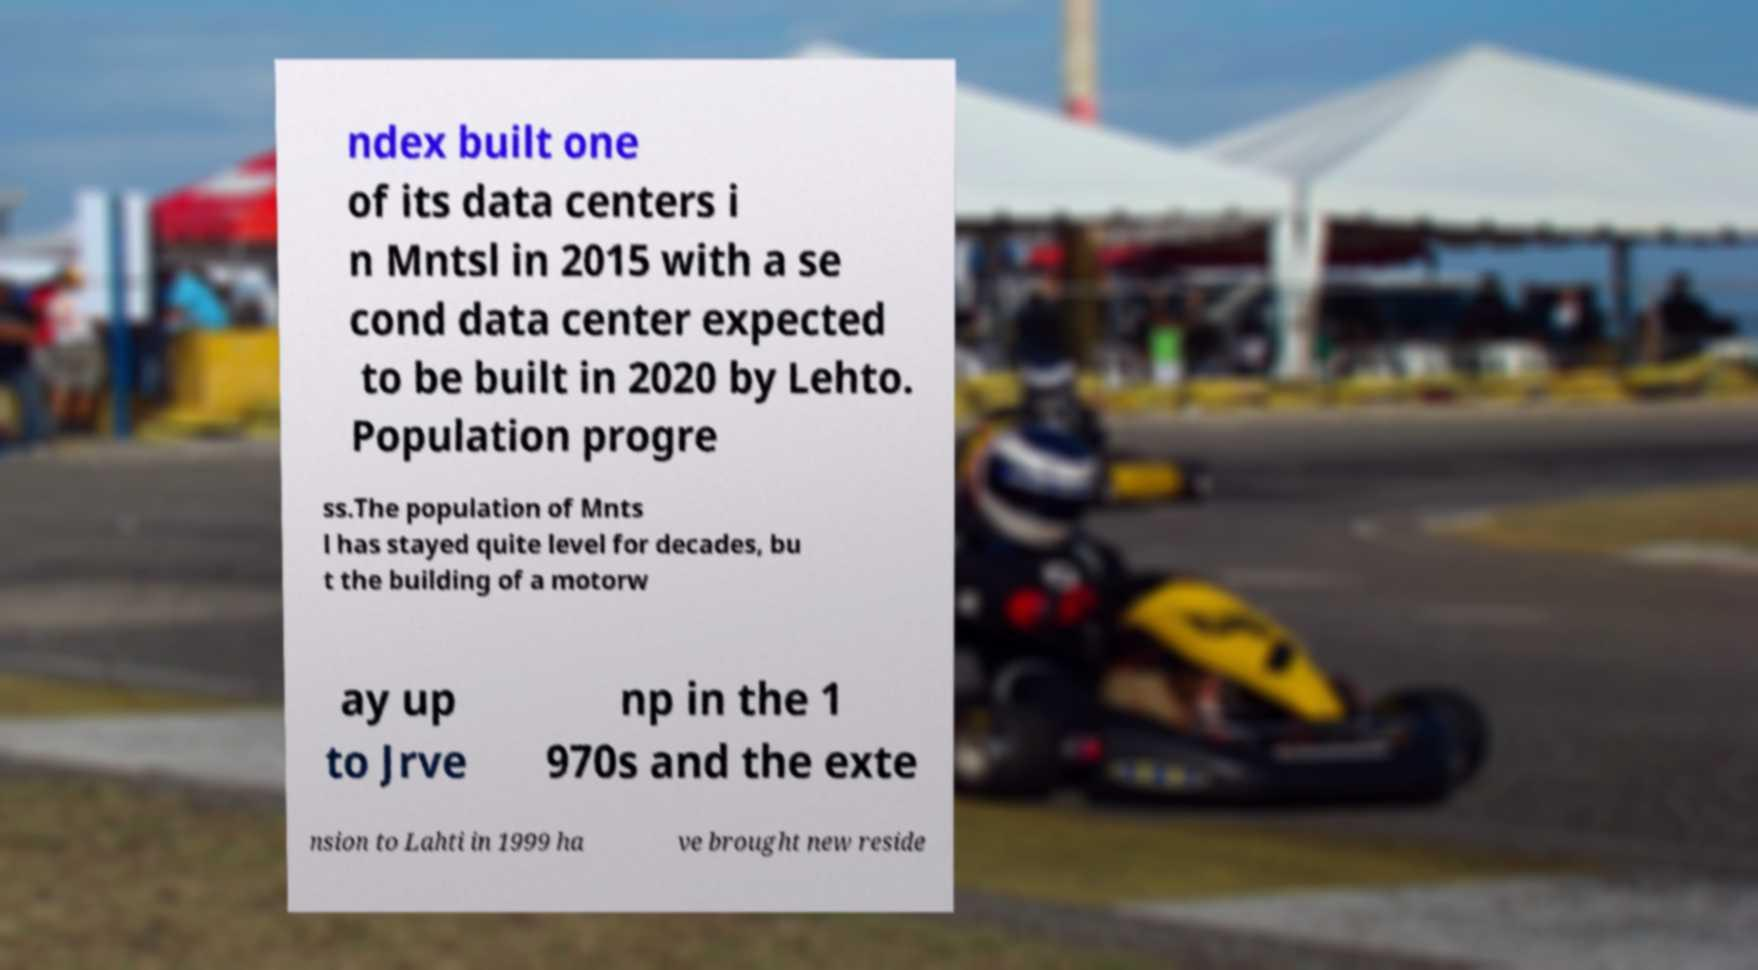What messages or text are displayed in this image? I need them in a readable, typed format. ndex built one of its data centers i n Mntsl in 2015 with a se cond data center expected to be built in 2020 by Lehto. Population progre ss.The population of Mnts l has stayed quite level for decades, bu t the building of a motorw ay up to Jrve np in the 1 970s and the exte nsion to Lahti in 1999 ha ve brought new reside 